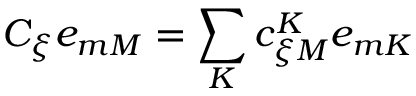Convert formula to latex. <formula><loc_0><loc_0><loc_500><loc_500>C _ { \xi } e _ { m M } = \sum _ { K } c _ { \xi M } ^ { K } e _ { m K }</formula> 